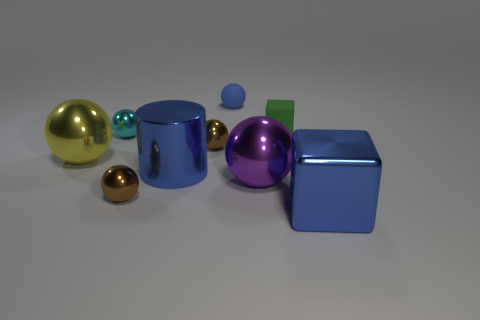The shiny object that is the same color as the shiny cylinder is what shape?
Ensure brevity in your answer.  Cube. What is the size of the cyan object that is the same shape as the tiny blue rubber object?
Your answer should be compact. Small. What is the ball behind the cyan object made of?
Your answer should be compact. Rubber. Is the number of cylinders to the right of the cylinder less than the number of tiny brown objects?
Ensure brevity in your answer.  Yes. There is a blue metallic thing to the right of the brown thing behind the big blue cylinder; what is its shape?
Your answer should be compact. Cube. What is the color of the large block?
Offer a very short reply. Blue. How many other objects are there of the same size as the blue shiny cube?
Offer a very short reply. 3. What is the material of the thing that is both behind the large yellow sphere and in front of the tiny cyan object?
Offer a terse response. Metal. There is a blue thing in front of the purple metallic ball; is it the same size as the blue cylinder?
Make the answer very short. Yes. Do the matte sphere and the shiny cylinder have the same color?
Make the answer very short. Yes. 